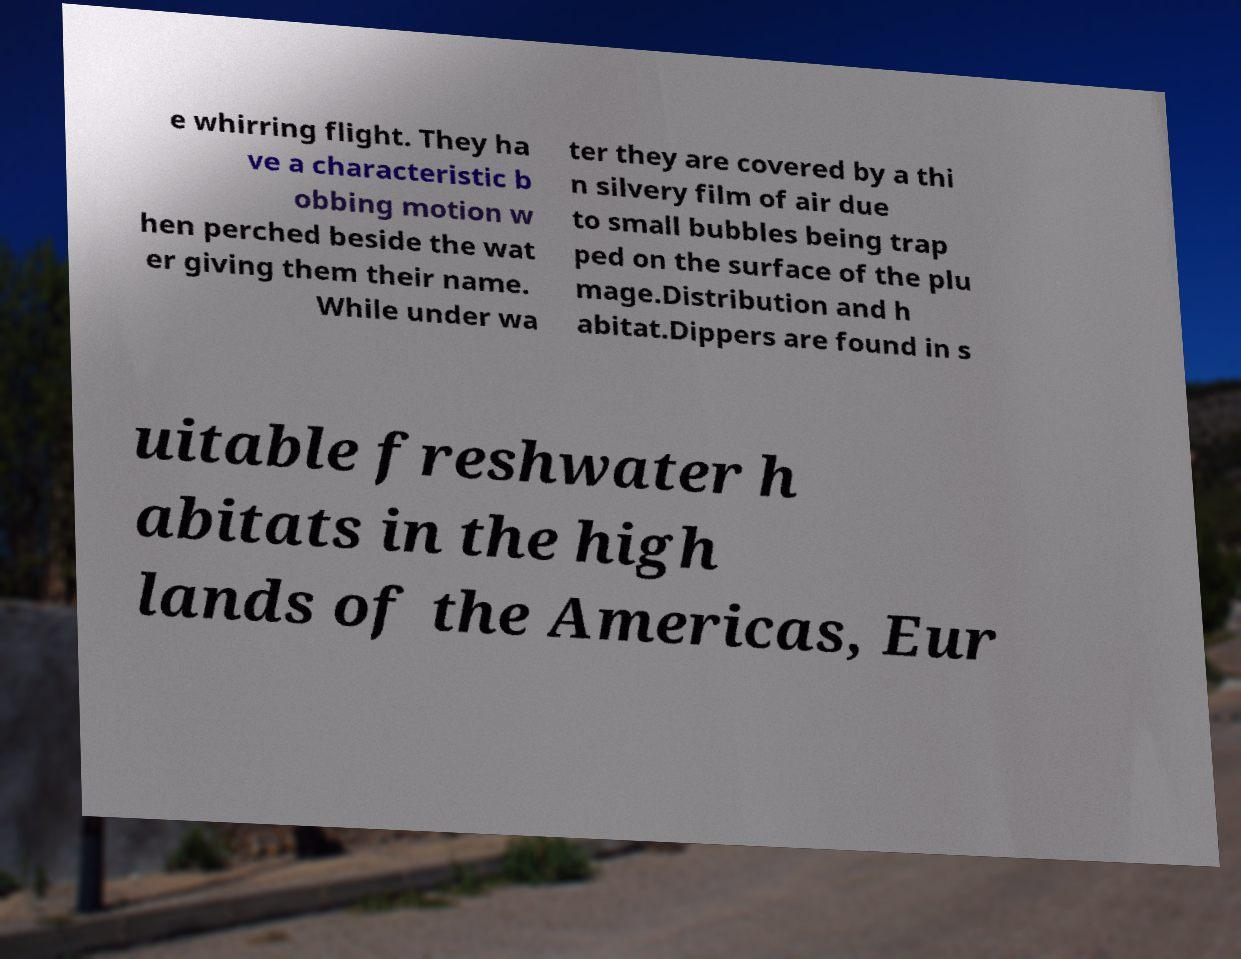For documentation purposes, I need the text within this image transcribed. Could you provide that? e whirring flight. They ha ve a characteristic b obbing motion w hen perched beside the wat er giving them their name. While under wa ter they are covered by a thi n silvery film of air due to small bubbles being trap ped on the surface of the plu mage.Distribution and h abitat.Dippers are found in s uitable freshwater h abitats in the high lands of the Americas, Eur 